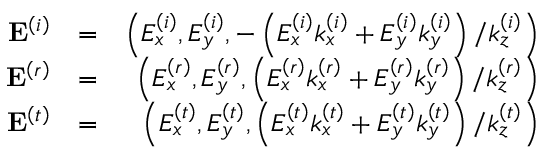<formula> <loc_0><loc_0><loc_500><loc_500>\begin{array} { r l r } { E ^ { \left ( i \right ) } } & { = } & { \left ( E _ { x } ^ { \left ( i \right ) } , E _ { y } ^ { \left ( i \right ) } , - \left ( E _ { x } ^ { \left ( i \right ) } k _ { x } ^ { \left ( i \right ) } + E _ { y } ^ { \left ( i \right ) } k _ { y } ^ { \left ( i \right ) } \right ) / k _ { z } ^ { \left ( i \right ) } \right ) } \\ { E ^ { \left ( r \right ) } } & { = } & { \left ( E _ { x } ^ { \left ( r \right ) } , E _ { y } ^ { \left ( r \right ) } , \left ( E _ { x } ^ { \left ( r \right ) } k _ { x } ^ { \left ( r \right ) } + E _ { y } ^ { \left ( r \right ) } k _ { y } ^ { \left ( r \right ) } \right ) / k _ { z } ^ { \left ( r \right ) } \right ) } \\ { E ^ { \left ( t \right ) } } & { = } & { \left ( E _ { x } ^ { \left ( t \right ) } , E _ { y } ^ { \left ( t \right ) } , \left ( E _ { x } ^ { \left ( t \right ) } k _ { x } ^ { \left ( t \right ) } + E _ { y } ^ { \left ( t \right ) } k _ { y } ^ { \left ( t \right ) } \right ) / k _ { z } ^ { \left ( t \right ) } \right ) } \end{array}</formula> 